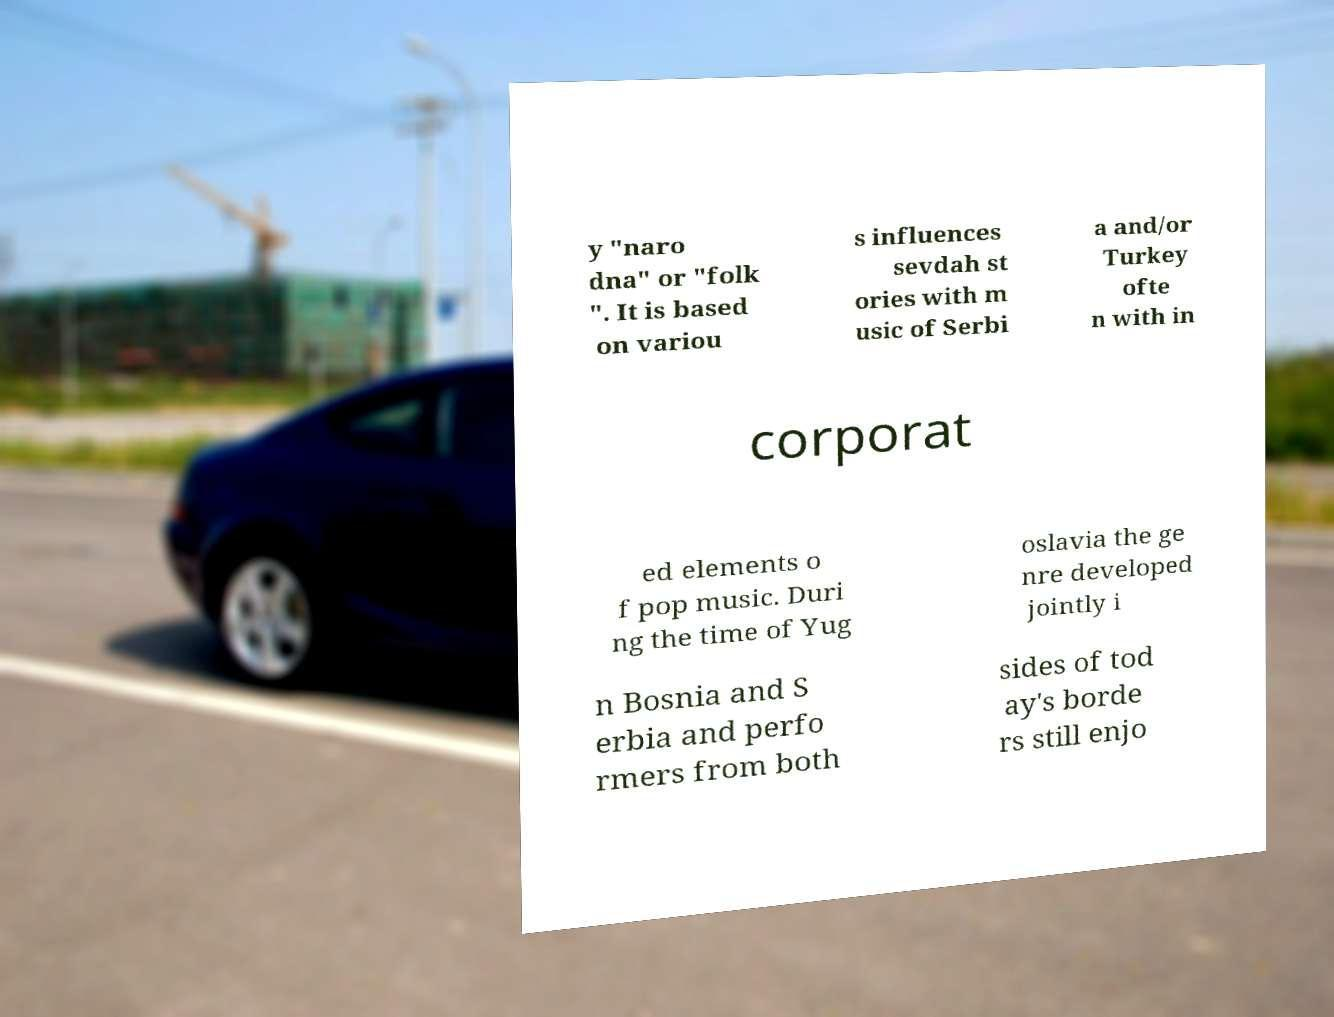I need the written content from this picture converted into text. Can you do that? y "naro dna" or "folk ". It is based on variou s influences sevdah st ories with m usic of Serbi a and/or Turkey ofte n with in corporat ed elements o f pop music. Duri ng the time of Yug oslavia the ge nre developed jointly i n Bosnia and S erbia and perfo rmers from both sides of tod ay's borde rs still enjo 